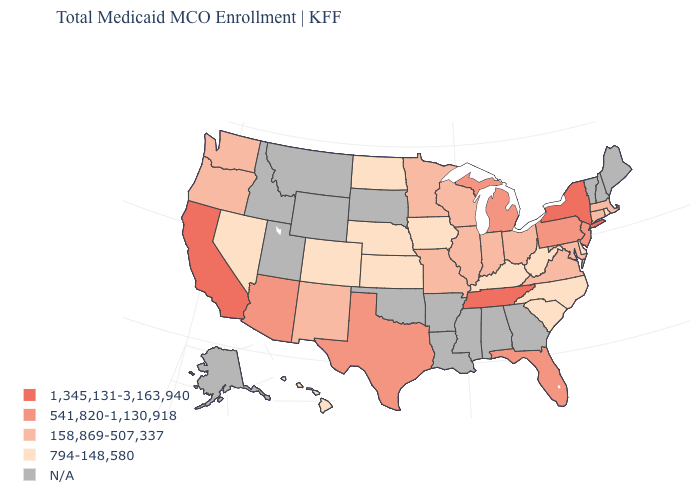What is the lowest value in the MidWest?
Give a very brief answer. 794-148,580. What is the value of West Virginia?
Quick response, please. 794-148,580. Among the states that border Idaho , which have the lowest value?
Quick response, please. Nevada. What is the value of Illinois?
Answer briefly. 158,869-507,337. Which states have the highest value in the USA?
Concise answer only. California, New York, Tennessee. Which states have the lowest value in the West?
Write a very short answer. Colorado, Hawaii, Nevada. What is the lowest value in the MidWest?
Give a very brief answer. 794-148,580. What is the highest value in the South ?
Answer briefly. 1,345,131-3,163,940. Which states have the lowest value in the USA?
Short answer required. Colorado, Delaware, Hawaii, Iowa, Kansas, Kentucky, Nebraska, Nevada, North Carolina, North Dakota, Rhode Island, South Carolina, West Virginia. Among the states that border Tennessee , which have the lowest value?
Write a very short answer. Kentucky, North Carolina. What is the value of Wisconsin?
Concise answer only. 158,869-507,337. Among the states that border Georgia , does North Carolina have the highest value?
Quick response, please. No. 